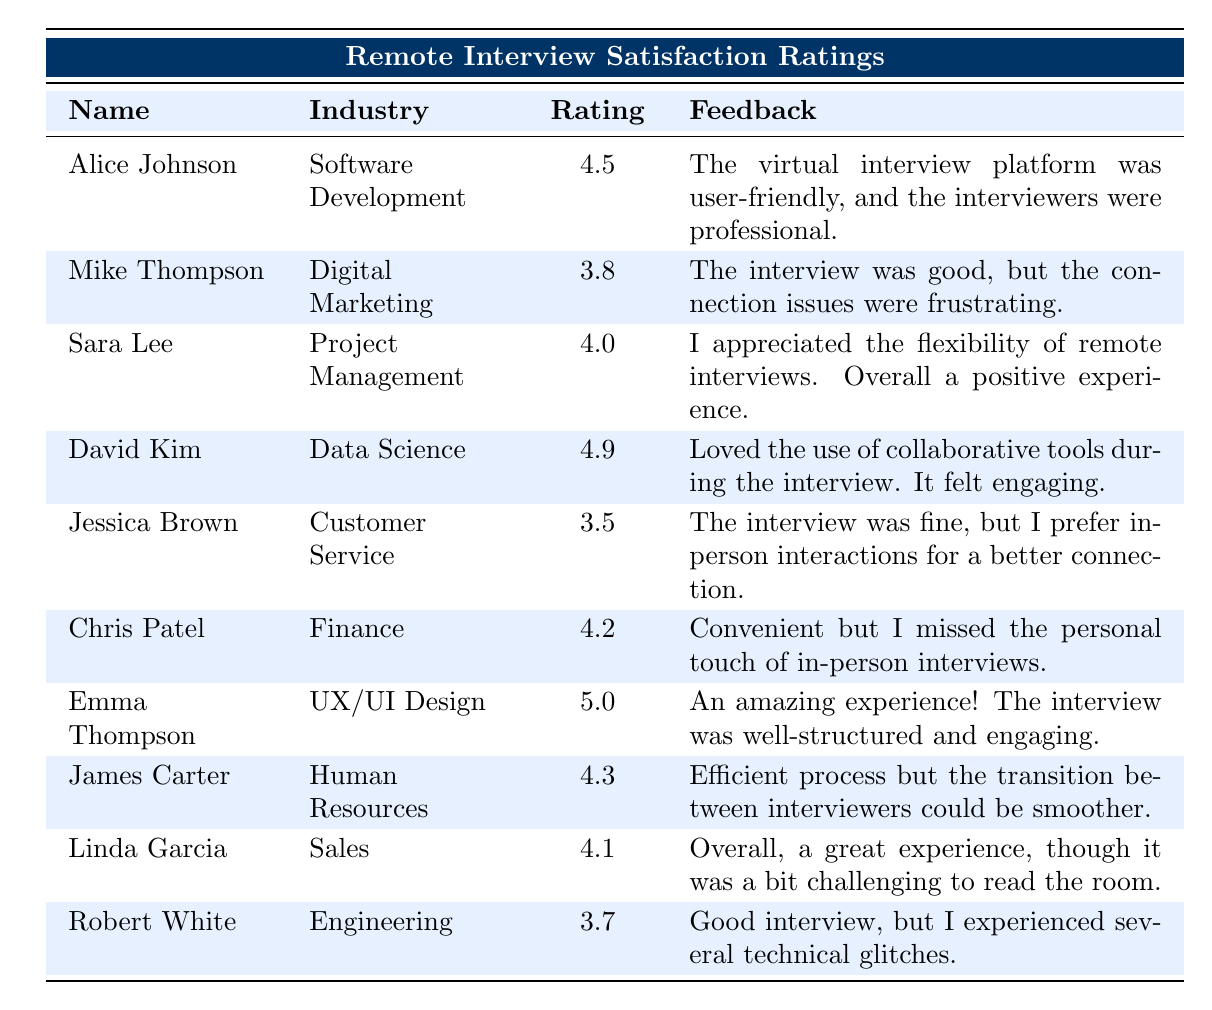What is the highest satisfaction rating recorded in the table? The table shows the satisfaction ratings for each job seeker. After reviewing the ratings, Emma Thompson has the highest rating of 5.0.
Answer: 5.0 Which job seeker works in Digital Marketing and what was their satisfaction rating? The table lists Mike Thompson as the job seeker in Digital Marketing with a satisfaction rating of 3.8.
Answer: Mike Thompson, 3.8 What is the average satisfaction rating of all the job seekers listed? To find the average, sum all the ratings: (4.5 + 3.8 + 4.0 + 4.9 + 3.5 + 4.2 + 5.0 + 4.3 + 4.1 + 3.7) = 43.0. There are 10 ratings, so the average is 43.0 / 10 = 4.3.
Answer: 4.3 Did any job seeker express a preference for in-person interviews? From the table, Jessica Brown explicitly stated that she prefers in-person interactions for a better connection, indicating she does prefer in-person interviews over remote ones.
Answer: Yes What is the difference between the highest and lowest satisfaction ratings? The highest rating is 5.0 (Emma Thompson) and the lowest is 3.5 (Jessica Brown). The difference is 5.0 - 3.5 = 1.5.
Answer: 1.5 Which industry had the most positive feedback about remote interviews regarding tools used? David Kim from Data Science provided positive feedback about using collaborative tools during the interview, stating it felt engaging.
Answer: Data Science Is it true that all satisfaction ratings are above 3.0? Reviewing the ratings, the lowest satisfaction rating is 3.5 (Jessica Brown), which means there are no ratings below 3.0. Therefore, the statement is true.
Answer: Yes Which job seeker felt that connection issues were a setback during their interview? Mike Thompson communicated in his feedback that connection issues were frustrating, indicating it affected his interview experience.
Answer: Mike Thompson What percentage of job seekers rated their remote interview experience 4.0 or higher? The ratings of 4.0 or higher are Alice Johnson, David Kim, Emma Thompson, Chris Patel, James Carter, and Linda Garcia, totaling 6 out of 10 job seekers. To find the percentage: (6/10) * 100 = 60%.
Answer: 60% 